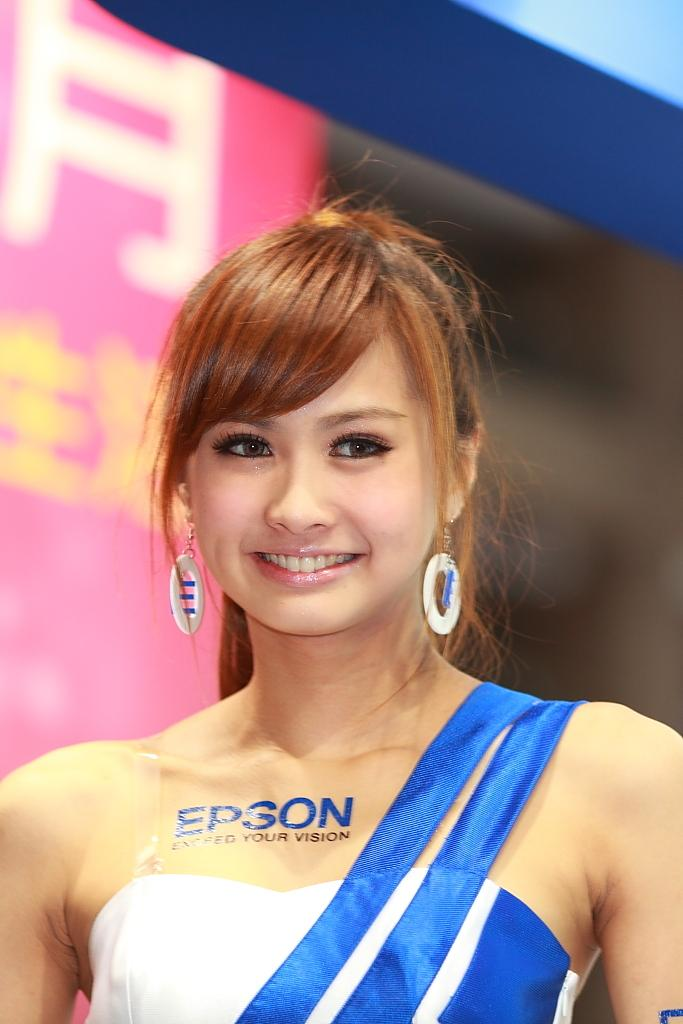<image>
Give a short and clear explanation of the subsequent image. a girl with the word epson on her body 